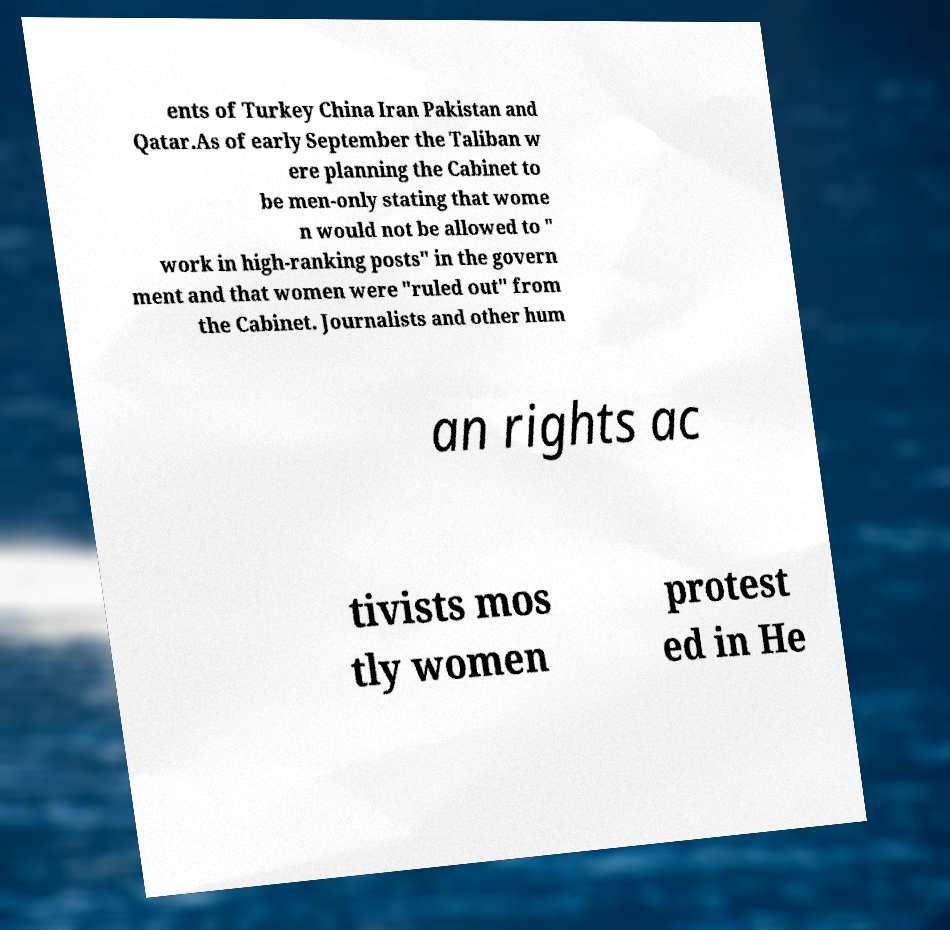Can you accurately transcribe the text from the provided image for me? ents of Turkey China Iran Pakistan and Qatar.As of early September the Taliban w ere planning the Cabinet to be men-only stating that wome n would not be allowed to " work in high-ranking posts" in the govern ment and that women were "ruled out" from the Cabinet. Journalists and other hum an rights ac tivists mos tly women protest ed in He 